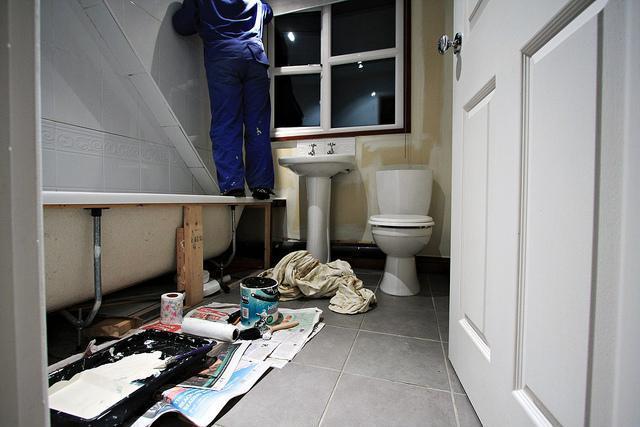How many frisbees are laying on the ground?
Give a very brief answer. 0. 